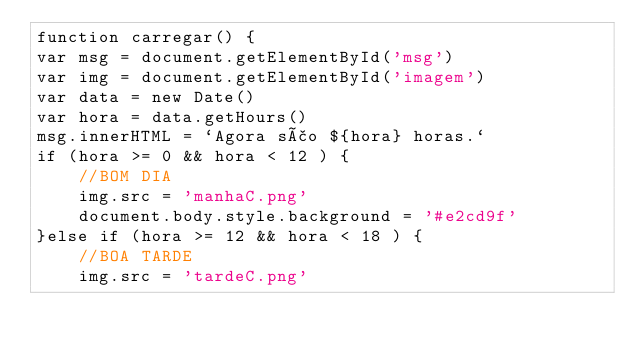<code> <loc_0><loc_0><loc_500><loc_500><_JavaScript_>function carregar() {
var msg = document.getElementById('msg')
var img = document.getElementById('imagem')
var data = new Date()
var hora = data.getHours()
msg.innerHTML = `Agora são ${hora} horas.`
if (hora >= 0 && hora < 12 ) {
    //BOM DIA 
    img.src = 'manhaC.png'
    document.body.style.background = '#e2cd9f'
}else if (hora >= 12 && hora < 18 ) {
    //BOA TARDE
    img.src = 'tardeC.png'</code> 